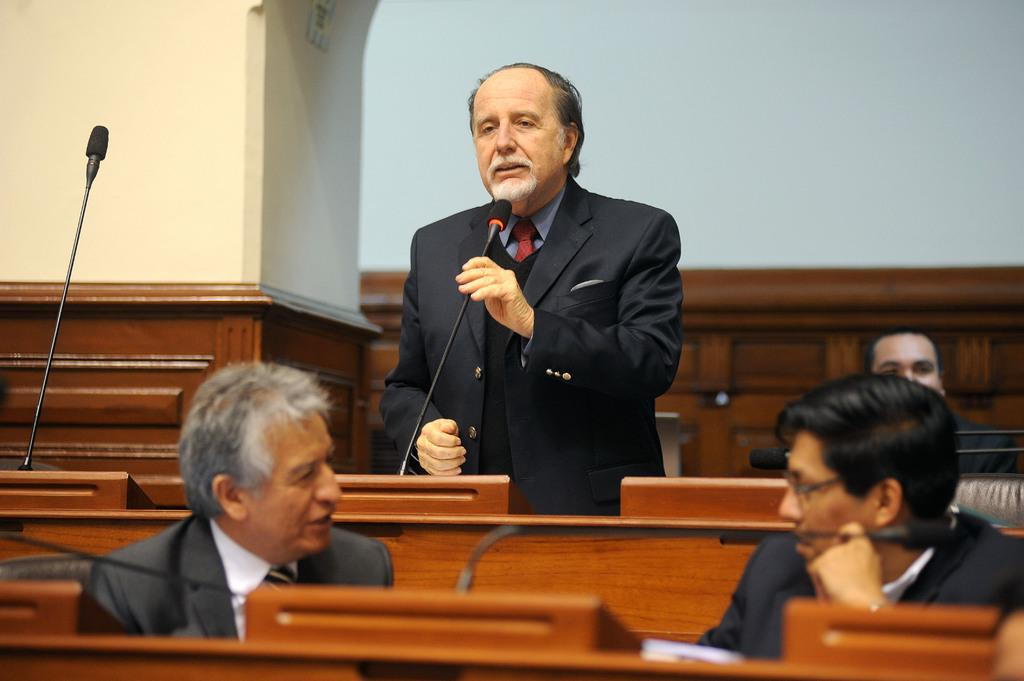What is the person in the image doing? The person is standing and holding a microphone. How many people are sitting in the image? There are three persons sitting in the image. What type of furniture is present in the image? There are chairs and a table in the image. What can be seen in the background of the image? There is a wall in the background of the image. What type of liquid is being poured from the card in the image? There is no card or liquid present in the image. 